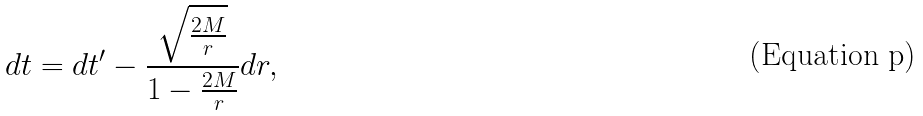Convert formula to latex. <formula><loc_0><loc_0><loc_500><loc_500>d t = d t ^ { \prime } - \frac { \sqrt { \frac { 2 M } { r } } } { 1 - \frac { 2 M } { r } } d r ,</formula> 